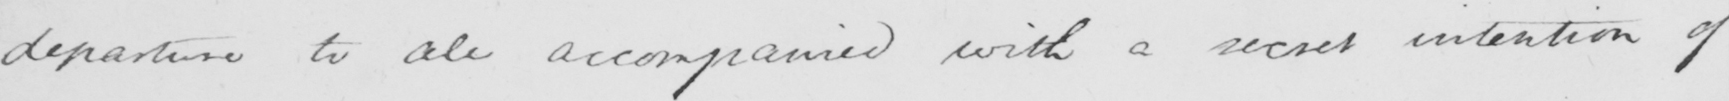What does this handwritten line say? departure to all accompanied with a secret intention of 